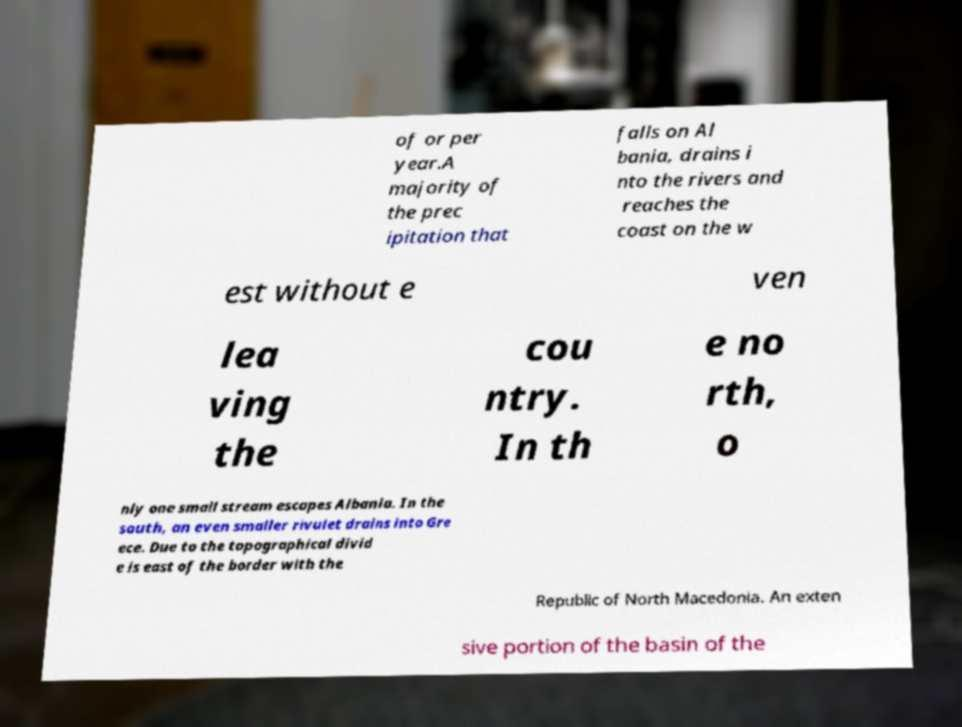Can you read and provide the text displayed in the image?This photo seems to have some interesting text. Can you extract and type it out for me? of or per year.A majority of the prec ipitation that falls on Al bania, drains i nto the rivers and reaches the coast on the w est without e ven lea ving the cou ntry. In th e no rth, o nly one small stream escapes Albania. In the south, an even smaller rivulet drains into Gre ece. Due to the topographical divid e is east of the border with the Republic of North Macedonia. An exten sive portion of the basin of the 